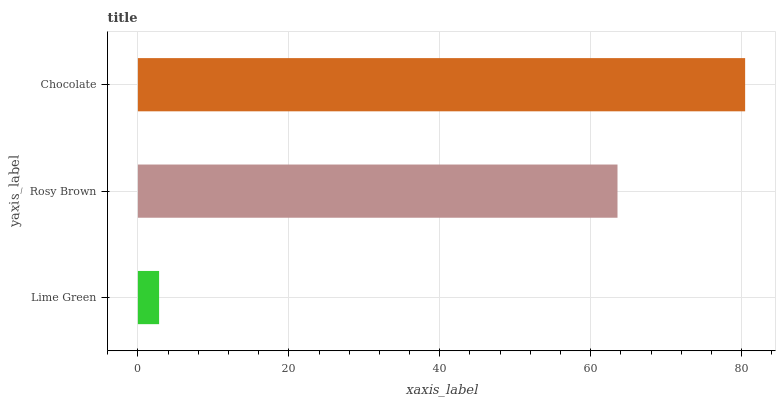Is Lime Green the minimum?
Answer yes or no. Yes. Is Chocolate the maximum?
Answer yes or no. Yes. Is Rosy Brown the minimum?
Answer yes or no. No. Is Rosy Brown the maximum?
Answer yes or no. No. Is Rosy Brown greater than Lime Green?
Answer yes or no. Yes. Is Lime Green less than Rosy Brown?
Answer yes or no. Yes. Is Lime Green greater than Rosy Brown?
Answer yes or no. No. Is Rosy Brown less than Lime Green?
Answer yes or no. No. Is Rosy Brown the high median?
Answer yes or no. Yes. Is Rosy Brown the low median?
Answer yes or no. Yes. Is Chocolate the high median?
Answer yes or no. No. Is Chocolate the low median?
Answer yes or no. No. 